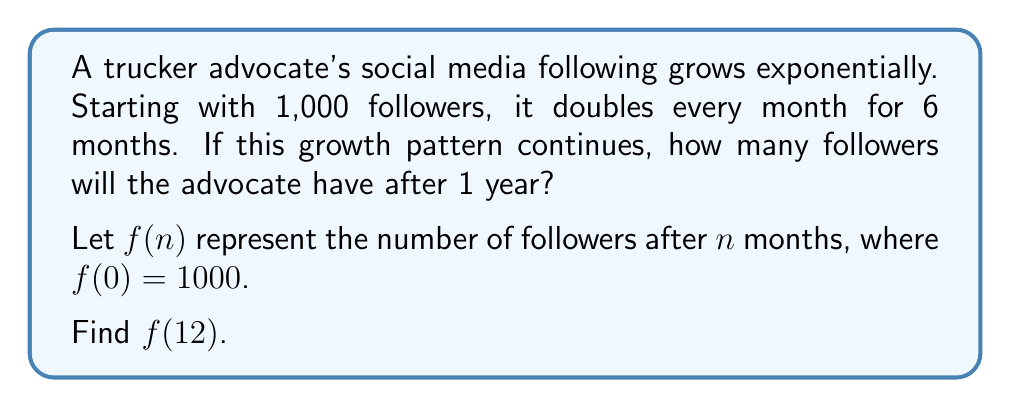Can you solve this math problem? Let's approach this step-by-step:

1) We're given that the initial number of followers is 1,000, so $f(0) = 1000$.

2) The number of followers doubles every month, so we can represent this as:
   $f(n) = 1000 \cdot 2^n$

3) After 6 months:
   $f(6) = 1000 \cdot 2^6 = 1000 \cdot 64 = 64,000$ followers

4) To find the number of followers after 1 year (12 months), we calculate:
   $f(12) = 1000 \cdot 2^{12}$

5) $2^{12}$ can be calculated as follows:
   $2^{12} = (2^6)^2 = 64^2 = 4,096$

6) Therefore:
   $f(12) = 1000 \cdot 4,096 = 4,096,000$

Thus, after 1 year (12 months), the trucker advocate will have 4,096,000 followers if this growth pattern continues.
Answer: 4,096,000 followers 